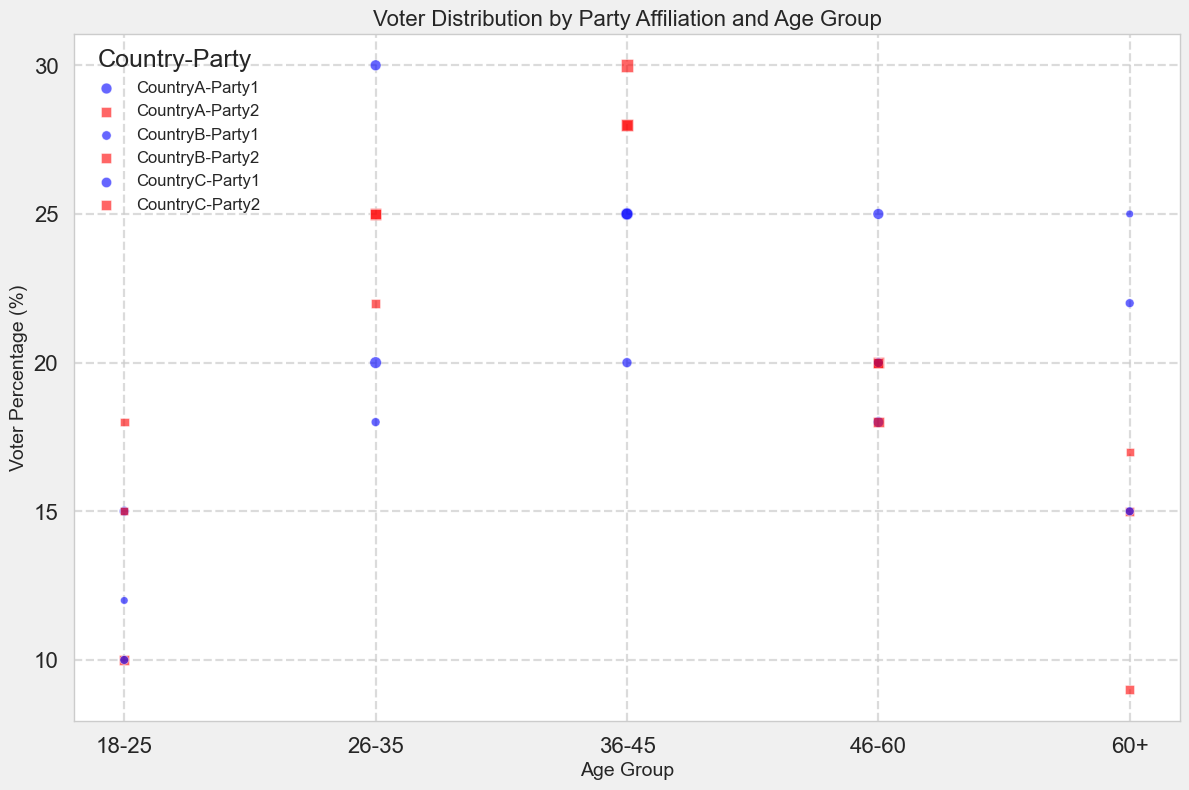What age group has the highest voter percentage for Party1 in CountryA? From the figure, we can identify the highest point for Party1 in CountryA on the y-axis (Voter Percentage). The 36-45 age group is the highest at 25%.
Answer: 36-45 Which party in CountryB has a higher voter percentage among the 46-60 age group? By comparing the bubbles for the 46-60 age group in CountryB, Party1 shows a voter percentage of 25%, while Party2 has 18%.
Answer: Party1 Which country has the largest bubble for the 18-25 age group for Party2, and what does it represent? By observing the size of the bubbles for the 18-25 age group for Party2, CountryA has the largest bubble. This represents a larger population in that age group for CountryA.
Answer: CountryA Which party in CountryC has a higher voter percentage for the 26-35 age group, and by how much? The voter percentage for Party1 in the 26-35 age group is 30%, while for Party2, it is 25%. The difference is 5%.
Answer: Party1, 5% What is the combined voter percentage for Party1 across all age groups in CountryB? Summing the voter percentages for Party1 in CountryB across all age groups: 12% + 18% + 20% + 25% + 25% = 100%.
Answer: 100% In which age group do Party2 voters have the lowest percentage in CountryC? By finding the lowest point for Party2 across all age groups in CountryC on the y-axis, the lowest voter percentage is in the 60+ age group at 9%.
Answer: 60+ How do the total voter percentages for Party1 and Party2 in CountryA compare for the 60+ age group? The voter percentage for Party1 in the 60+ age group in CountryA is 22%, while for Party2, it is 15%. Therefore, Party1 has a 7% higher voter percentage.
Answer: Party1, 7% Which party has more consistent voter percentages across age groups in CountryB? Consistency can be judged by the relatively similar heights of the bubbles across age groups. Party1 shows less variation (12%, 18%, 20%, 25%, 25%), while Party2 has more variation.
Answer: Party1 What is the difference in voter percentages between the 18-25 and the 46-60 age groups for Party1 in CountryA? The voter percentage for the 18-25 age group is 15% and for the 46-60 age group is 18% for Party1 in CountryA. The difference is 3%.
Answer: 3% What visual attributes indicate Party2 in CountryC's voter percentage in the 36-45 age group? The figure shows a red square bubble. By its vertical position, it has a voter percentage of 28%.
Answer: Red square, 28% 